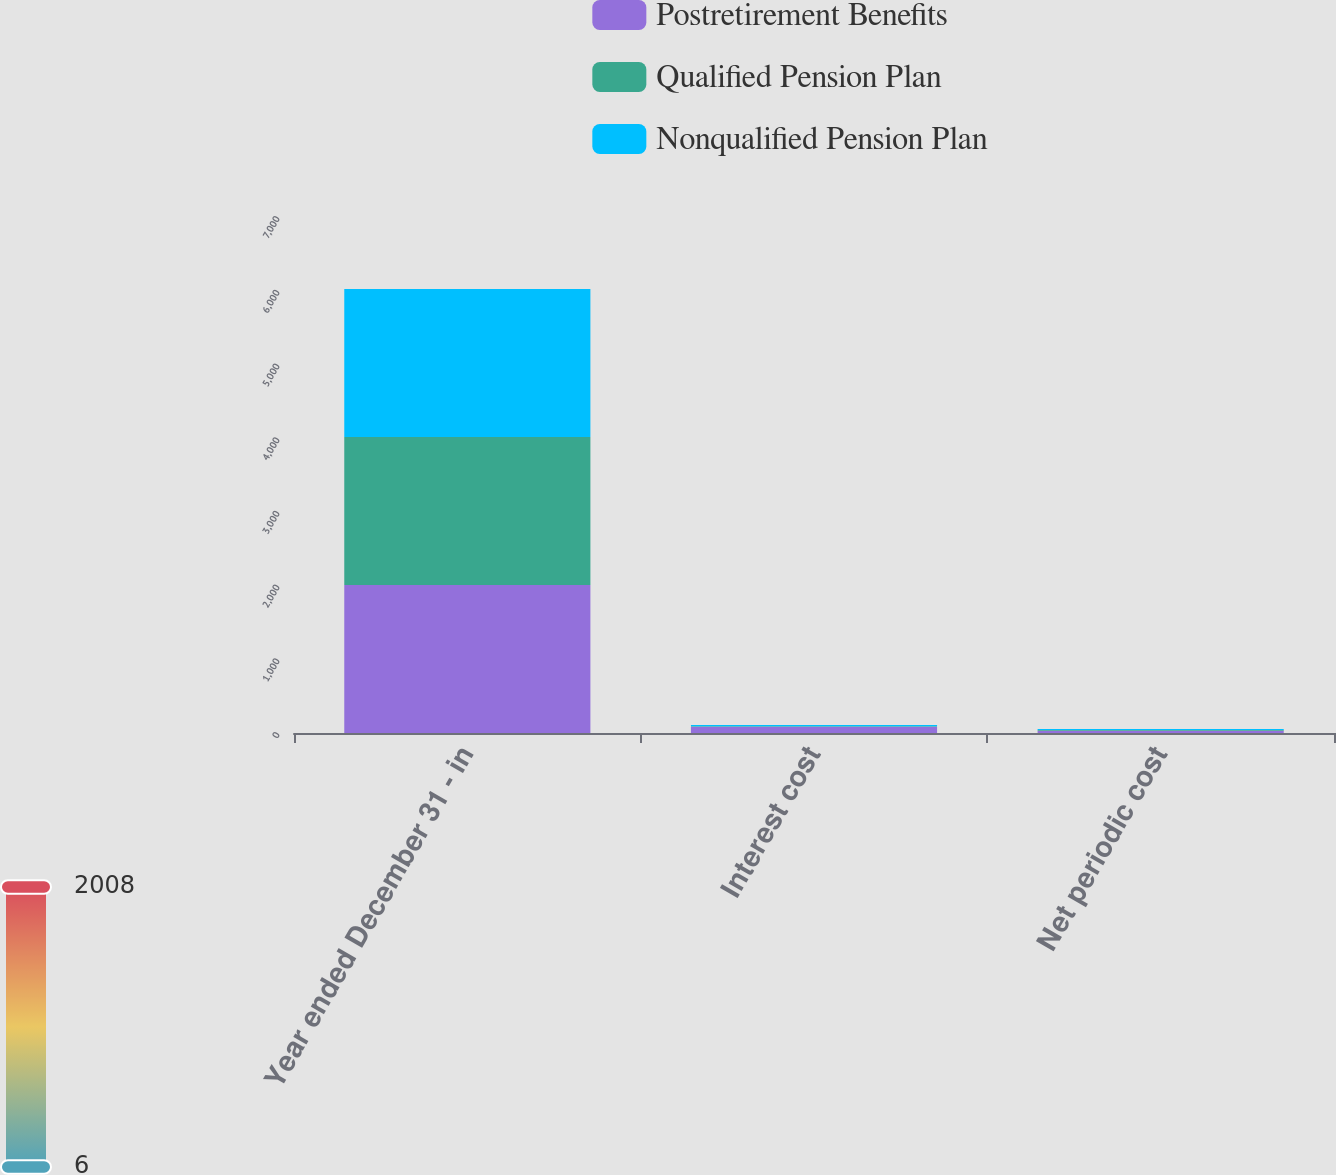Convert chart to OTSL. <chart><loc_0><loc_0><loc_500><loc_500><stacked_bar_chart><ecel><fcel>Year ended December 31 - in<fcel>Interest cost<fcel>Net periodic cost<nl><fcel>Postretirement Benefits<fcel>2008<fcel>86<fcel>32<nl><fcel>Qualified Pension Plan<fcel>2008<fcel>6<fcel>10<nl><fcel>Nonqualified Pension Plan<fcel>2008<fcel>15<fcel>11<nl></chart> 